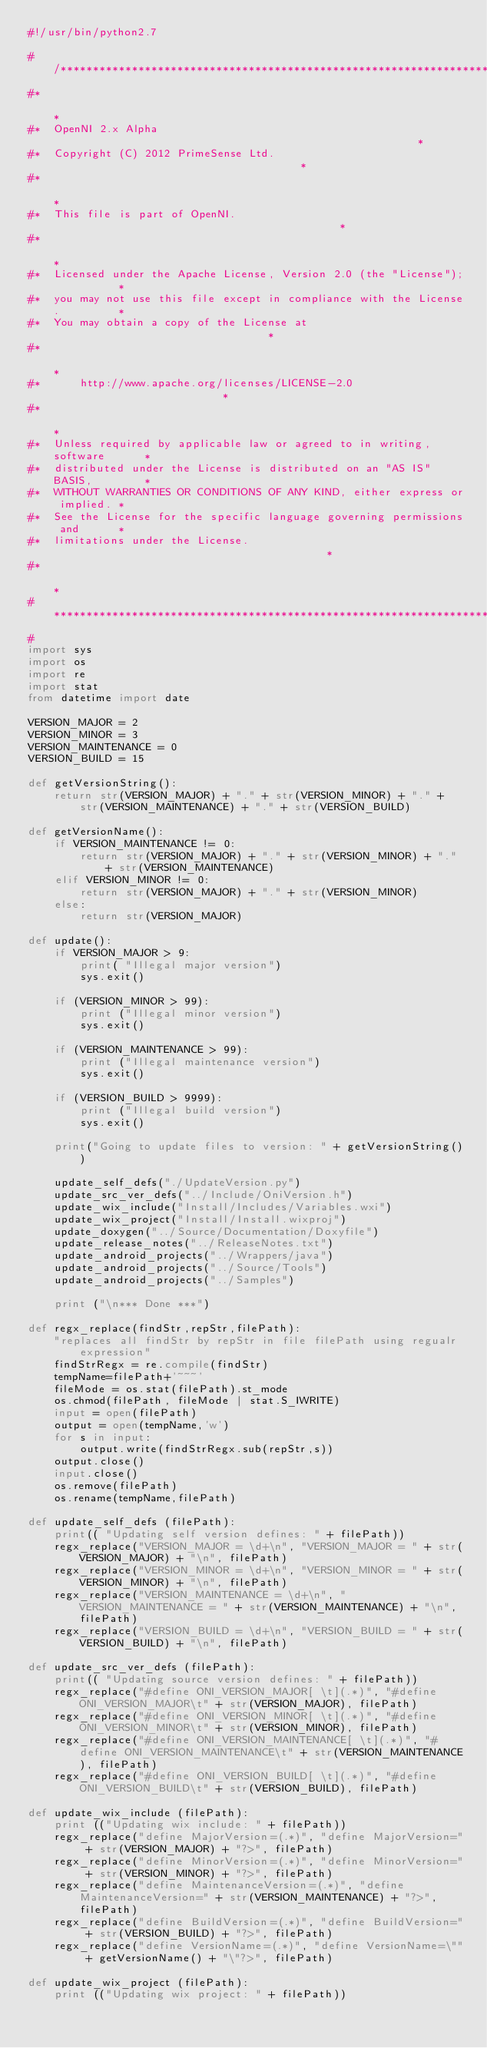Convert code to text. <code><loc_0><loc_0><loc_500><loc_500><_Python_>#!/usr/bin/python2.7

#/****************************************************************************
#*                                                                           *
#*  OpenNI 2.x Alpha                                                         *
#*  Copyright (C) 2012 PrimeSense Ltd.                                       *
#*                                                                           *
#*  This file is part of OpenNI.                                             *
#*                                                                           *
#*  Licensed under the Apache License, Version 2.0 (the "License");          *
#*  you may not use this file except in compliance with the License.         *
#*  You may obtain a copy of the License at                                  *
#*                                                                           *
#*      http://www.apache.org/licenses/LICENSE-2.0                           *
#*                                                                           *
#*  Unless required by applicable law or agreed to in writing, software      *
#*  distributed under the License is distributed on an "AS IS" BASIS,        *
#*  WITHOUT WARRANTIES OR CONDITIONS OF ANY KIND, either express or implied. *
#*  See the License for the specific language governing permissions and      *
#*  limitations under the License.                                           *
#*                                                                           *
#****************************************************************************/
#
import sys
import os
import re
import stat
from datetime import date

VERSION_MAJOR = 2
VERSION_MINOR = 3
VERSION_MAINTENANCE = 0
VERSION_BUILD = 15

def getVersionString():
    return str(VERSION_MAJOR) + "." + str(VERSION_MINOR) + "." + str(VERSION_MAINTENANCE) + "." + str(VERSION_BUILD)
    
def getVersionName():
    if VERSION_MAINTENANCE != 0:
        return str(VERSION_MAJOR) + "." + str(VERSION_MINOR) + "." + str(VERSION_MAINTENANCE)
    elif VERSION_MINOR != 0:
        return str(VERSION_MAJOR) + "." + str(VERSION_MINOR)
    else:
        return str(VERSION_MAJOR)

def update():
    if VERSION_MAJOR > 9:
        print( "Illegal major version")
        sys.exit()

    if (VERSION_MINOR > 99):
        print ("Illegal minor version")
        sys.exit()

    if (VERSION_MAINTENANCE > 99):
        print ("Illegal maintenance version")
        sys.exit()

    if (VERSION_BUILD > 9999):
        print ("Illegal build version")
        sys.exit()

    print("Going to update files to version: " + getVersionString())

    update_self_defs("./UpdateVersion.py")
    update_src_ver_defs("../Include/OniVersion.h")
    update_wix_include("Install/Includes/Variables.wxi")
    update_wix_project("Install/Install.wixproj")
    update_doxygen("../Source/Documentation/Doxyfile")
    update_release_notes("../ReleaseNotes.txt")
    update_android_projects("../Wrappers/java")
    update_android_projects("../Source/Tools")
    update_android_projects("../Samples")

    print ("\n*** Done ***")

def regx_replace(findStr,repStr,filePath):
    "replaces all findStr by repStr in file filePath using regualr expression"
    findStrRegx = re.compile(findStr)
    tempName=filePath+'~~~'
    fileMode = os.stat(filePath).st_mode
    os.chmod(filePath, fileMode | stat.S_IWRITE)
    input = open(filePath)
    output = open(tempName,'w')
    for s in input:
        output.write(findStrRegx.sub(repStr,s))
    output.close()
    input.close()
    os.remove(filePath)
    os.rename(tempName,filePath)

def update_self_defs (filePath):
    print(( "Updating self version defines: " + filePath))
    regx_replace("VERSION_MAJOR = \d+\n", "VERSION_MAJOR = " + str(VERSION_MAJOR) + "\n", filePath)
    regx_replace("VERSION_MINOR = \d+\n", "VERSION_MINOR = " + str(VERSION_MINOR) + "\n", filePath)
    regx_replace("VERSION_MAINTENANCE = \d+\n", "VERSION_MAINTENANCE = " + str(VERSION_MAINTENANCE) + "\n", filePath)
    regx_replace("VERSION_BUILD = \d+\n", "VERSION_BUILD = " + str(VERSION_BUILD) + "\n", filePath)

def update_src_ver_defs (filePath):
    print(( "Updating source version defines: " + filePath))
    regx_replace("#define ONI_VERSION_MAJOR[ \t](.*)", "#define ONI_VERSION_MAJOR\t" + str(VERSION_MAJOR), filePath)
    regx_replace("#define ONI_VERSION_MINOR[ \t](.*)", "#define ONI_VERSION_MINOR\t" + str(VERSION_MINOR), filePath)
    regx_replace("#define ONI_VERSION_MAINTENANCE[ \t](.*)", "#define ONI_VERSION_MAINTENANCE\t" + str(VERSION_MAINTENANCE), filePath)
    regx_replace("#define ONI_VERSION_BUILD[ \t](.*)", "#define ONI_VERSION_BUILD\t" + str(VERSION_BUILD), filePath)

def update_wix_include (filePath):
    print (("Updating wix include: " + filePath))
    regx_replace("define MajorVersion=(.*)", "define MajorVersion=" + str(VERSION_MAJOR) + "?>", filePath)
    regx_replace("define MinorVersion=(.*)", "define MinorVersion=" + str(VERSION_MINOR) + "?>", filePath)
    regx_replace("define MaintenanceVersion=(.*)", "define MaintenanceVersion=" + str(VERSION_MAINTENANCE) + "?>", filePath)
    regx_replace("define BuildVersion=(.*)", "define BuildVersion=" + str(VERSION_BUILD) + "?>", filePath)
    regx_replace("define VersionName=(.*)", "define VersionName=\"" + getVersionName() + "\"?>", filePath)

def update_wix_project (filePath):
    print (("Updating wix project: " + filePath))</code> 